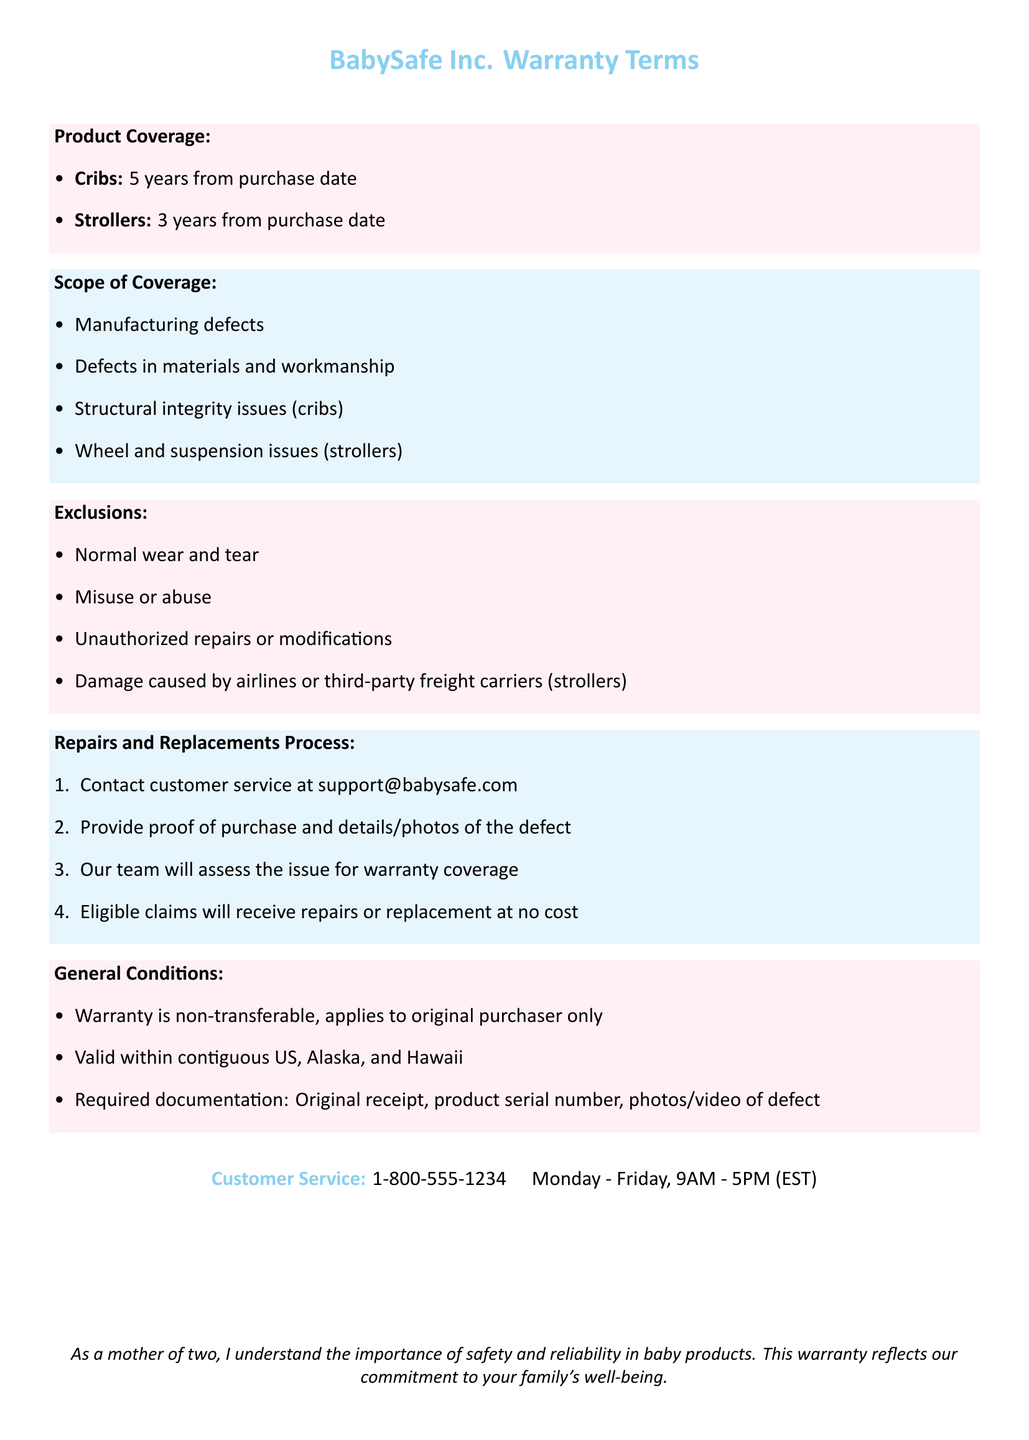What is the warranty duration for cribs? The warranty duration for cribs is specified in the document as 5 years from the purchase date.
Answer: 5 years What types of issues does the warranty cover for strollers? The document outlines specific issues covered by the warranty for strollers, which include wheel and suspension issues.
Answer: Wheel and suspension issues Are normal wear and tear covered by the warranty? The document lists exclusions to the warranty, which specifically includes normal wear and tear.
Answer: No What is required to submit a warranty claim? The document mentions necessary documentation for submitting a warranty claim, which includes original receipt and product serial number.
Answer: Original receipt, product serial number How can one contact customer service? The document provides a specific method for contacting customer service, which is via the phone number listed.
Answer: 1-800-555-1234 How long is the warranty for strollers? The document specifies the warranty duration for strollers as 3 years from the purchase date.
Answer: 3 years Is the warranty transferable? The document states that the warranty is non-transferable and applies only to the original purchaser.
Answer: No What type of defects are covered under the warranty? The document outlines that manufacturing defects and defects in materials and workmanship are covered under the warranty.
Answer: Manufacturing defects, defects in materials and workmanship Where is the warranty valid? The document indicates that the warranty is valid within contiguous US, Alaska, and Hawaii.
Answer: Contiguous US, Alaska, and Hawaii 